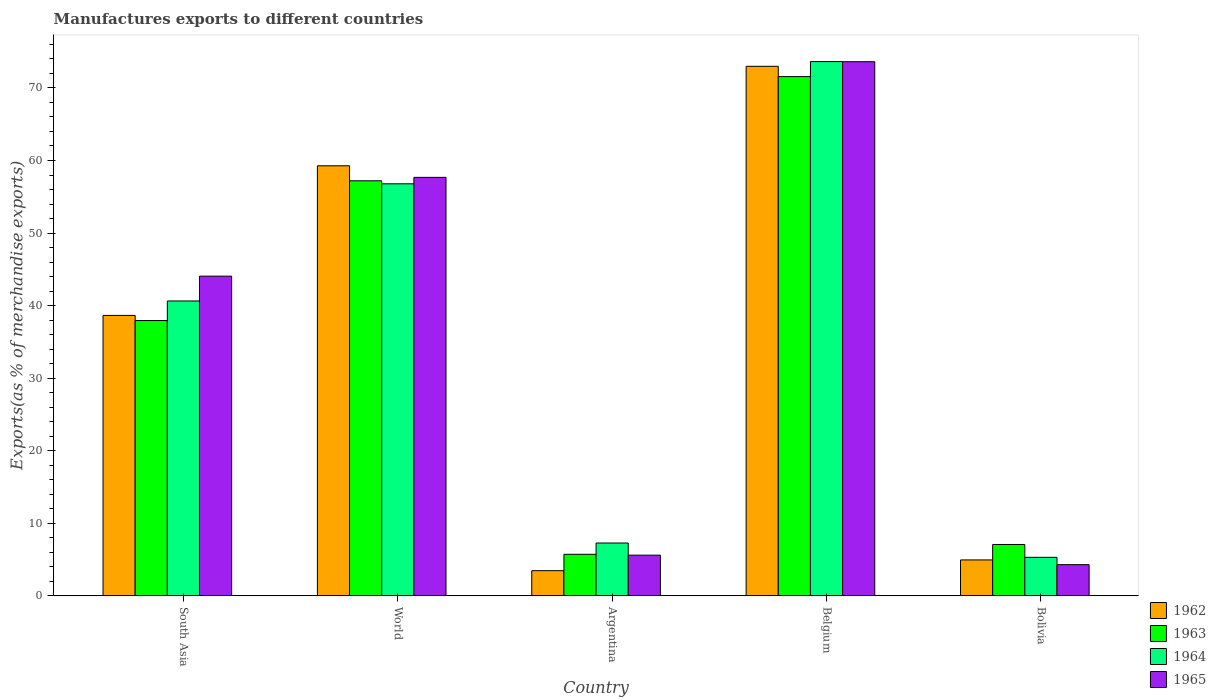How many different coloured bars are there?
Give a very brief answer. 4. How many groups of bars are there?
Provide a succinct answer. 5. Are the number of bars per tick equal to the number of legend labels?
Offer a terse response. Yes. How many bars are there on the 3rd tick from the right?
Your answer should be compact. 4. What is the label of the 3rd group of bars from the left?
Your answer should be very brief. Argentina. What is the percentage of exports to different countries in 1965 in World?
Offer a terse response. 57.68. Across all countries, what is the maximum percentage of exports to different countries in 1962?
Your response must be concise. 72.98. Across all countries, what is the minimum percentage of exports to different countries in 1964?
Provide a short and direct response. 5.31. What is the total percentage of exports to different countries in 1965 in the graph?
Offer a terse response. 185.26. What is the difference between the percentage of exports to different countries in 1965 in Bolivia and that in World?
Keep it short and to the point. -53.38. What is the difference between the percentage of exports to different countries in 1965 in Belgium and the percentage of exports to different countries in 1963 in South Asia?
Provide a short and direct response. 35.68. What is the average percentage of exports to different countries in 1963 per country?
Offer a very short reply. 35.9. What is the difference between the percentage of exports to different countries of/in 1962 and percentage of exports to different countries of/in 1963 in Belgium?
Your answer should be compact. 1.42. In how many countries, is the percentage of exports to different countries in 1962 greater than 20 %?
Provide a succinct answer. 3. What is the ratio of the percentage of exports to different countries in 1965 in Belgium to that in South Asia?
Offer a terse response. 1.67. What is the difference between the highest and the second highest percentage of exports to different countries in 1965?
Provide a succinct answer. 29.56. What is the difference between the highest and the lowest percentage of exports to different countries in 1965?
Your answer should be very brief. 69.32. Is the sum of the percentage of exports to different countries in 1963 in Argentina and Bolivia greater than the maximum percentage of exports to different countries in 1962 across all countries?
Make the answer very short. No. What does the 3rd bar from the left in Argentina represents?
Give a very brief answer. 1964. What does the 2nd bar from the right in Belgium represents?
Provide a short and direct response. 1964. Is it the case that in every country, the sum of the percentage of exports to different countries in 1963 and percentage of exports to different countries in 1964 is greater than the percentage of exports to different countries in 1962?
Offer a terse response. Yes. Are all the bars in the graph horizontal?
Offer a very short reply. No. What is the difference between two consecutive major ticks on the Y-axis?
Your response must be concise. 10. Are the values on the major ticks of Y-axis written in scientific E-notation?
Provide a succinct answer. No. Where does the legend appear in the graph?
Make the answer very short. Bottom right. What is the title of the graph?
Your answer should be very brief. Manufactures exports to different countries. What is the label or title of the Y-axis?
Offer a very short reply. Exports(as % of merchandise exports). What is the Exports(as % of merchandise exports) of 1962 in South Asia?
Ensure brevity in your answer.  38.65. What is the Exports(as % of merchandise exports) of 1963 in South Asia?
Your answer should be very brief. 37.94. What is the Exports(as % of merchandise exports) of 1964 in South Asia?
Your answer should be compact. 40.64. What is the Exports(as % of merchandise exports) in 1965 in South Asia?
Keep it short and to the point. 44.06. What is the Exports(as % of merchandise exports) of 1962 in World?
Offer a terse response. 59.27. What is the Exports(as % of merchandise exports) of 1963 in World?
Your answer should be very brief. 57.2. What is the Exports(as % of merchandise exports) in 1964 in World?
Offer a terse response. 56.79. What is the Exports(as % of merchandise exports) in 1965 in World?
Make the answer very short. 57.68. What is the Exports(as % of merchandise exports) of 1962 in Argentina?
Offer a very short reply. 3.47. What is the Exports(as % of merchandise exports) in 1963 in Argentina?
Give a very brief answer. 5.73. What is the Exports(as % of merchandise exports) in 1964 in Argentina?
Your answer should be compact. 7.28. What is the Exports(as % of merchandise exports) in 1965 in Argentina?
Your answer should be very brief. 5.61. What is the Exports(as % of merchandise exports) of 1962 in Belgium?
Your answer should be compact. 72.98. What is the Exports(as % of merchandise exports) of 1963 in Belgium?
Provide a short and direct response. 71.56. What is the Exports(as % of merchandise exports) in 1964 in Belgium?
Your answer should be very brief. 73.63. What is the Exports(as % of merchandise exports) of 1965 in Belgium?
Ensure brevity in your answer.  73.62. What is the Exports(as % of merchandise exports) in 1962 in Bolivia?
Your response must be concise. 4.95. What is the Exports(as % of merchandise exports) of 1963 in Bolivia?
Your answer should be very brief. 7.08. What is the Exports(as % of merchandise exports) of 1964 in Bolivia?
Provide a succinct answer. 5.31. What is the Exports(as % of merchandise exports) of 1965 in Bolivia?
Provide a succinct answer. 4.3. Across all countries, what is the maximum Exports(as % of merchandise exports) of 1962?
Your response must be concise. 72.98. Across all countries, what is the maximum Exports(as % of merchandise exports) in 1963?
Offer a terse response. 71.56. Across all countries, what is the maximum Exports(as % of merchandise exports) of 1964?
Offer a terse response. 73.63. Across all countries, what is the maximum Exports(as % of merchandise exports) of 1965?
Your answer should be compact. 73.62. Across all countries, what is the minimum Exports(as % of merchandise exports) of 1962?
Ensure brevity in your answer.  3.47. Across all countries, what is the minimum Exports(as % of merchandise exports) of 1963?
Give a very brief answer. 5.73. Across all countries, what is the minimum Exports(as % of merchandise exports) in 1964?
Offer a terse response. 5.31. Across all countries, what is the minimum Exports(as % of merchandise exports) of 1965?
Offer a very short reply. 4.3. What is the total Exports(as % of merchandise exports) in 1962 in the graph?
Provide a succinct answer. 179.32. What is the total Exports(as % of merchandise exports) in 1963 in the graph?
Keep it short and to the point. 179.51. What is the total Exports(as % of merchandise exports) in 1964 in the graph?
Offer a terse response. 183.65. What is the total Exports(as % of merchandise exports) in 1965 in the graph?
Your response must be concise. 185.26. What is the difference between the Exports(as % of merchandise exports) in 1962 in South Asia and that in World?
Offer a terse response. -20.62. What is the difference between the Exports(as % of merchandise exports) of 1963 in South Asia and that in World?
Keep it short and to the point. -19.26. What is the difference between the Exports(as % of merchandise exports) of 1964 in South Asia and that in World?
Keep it short and to the point. -16.15. What is the difference between the Exports(as % of merchandise exports) in 1965 in South Asia and that in World?
Provide a short and direct response. -13.62. What is the difference between the Exports(as % of merchandise exports) of 1962 in South Asia and that in Argentina?
Make the answer very short. 35.18. What is the difference between the Exports(as % of merchandise exports) in 1963 in South Asia and that in Argentina?
Offer a terse response. 32.21. What is the difference between the Exports(as % of merchandise exports) in 1964 in South Asia and that in Argentina?
Your response must be concise. 33.36. What is the difference between the Exports(as % of merchandise exports) of 1965 in South Asia and that in Argentina?
Your answer should be very brief. 38.45. What is the difference between the Exports(as % of merchandise exports) of 1962 in South Asia and that in Belgium?
Keep it short and to the point. -34.33. What is the difference between the Exports(as % of merchandise exports) in 1963 in South Asia and that in Belgium?
Make the answer very short. -33.62. What is the difference between the Exports(as % of merchandise exports) of 1964 in South Asia and that in Belgium?
Provide a short and direct response. -32.99. What is the difference between the Exports(as % of merchandise exports) in 1965 in South Asia and that in Belgium?
Provide a succinct answer. -29.56. What is the difference between the Exports(as % of merchandise exports) in 1962 in South Asia and that in Bolivia?
Your answer should be very brief. 33.7. What is the difference between the Exports(as % of merchandise exports) of 1963 in South Asia and that in Bolivia?
Provide a short and direct response. 30.86. What is the difference between the Exports(as % of merchandise exports) in 1964 in South Asia and that in Bolivia?
Your response must be concise. 35.33. What is the difference between the Exports(as % of merchandise exports) of 1965 in South Asia and that in Bolivia?
Keep it short and to the point. 39.76. What is the difference between the Exports(as % of merchandise exports) of 1962 in World and that in Argentina?
Keep it short and to the point. 55.8. What is the difference between the Exports(as % of merchandise exports) in 1963 in World and that in Argentina?
Offer a terse response. 51.48. What is the difference between the Exports(as % of merchandise exports) of 1964 in World and that in Argentina?
Your response must be concise. 49.51. What is the difference between the Exports(as % of merchandise exports) of 1965 in World and that in Argentina?
Provide a short and direct response. 52.07. What is the difference between the Exports(as % of merchandise exports) in 1962 in World and that in Belgium?
Your answer should be very brief. -13.71. What is the difference between the Exports(as % of merchandise exports) in 1963 in World and that in Belgium?
Make the answer very short. -14.36. What is the difference between the Exports(as % of merchandise exports) in 1964 in World and that in Belgium?
Offer a terse response. -16.84. What is the difference between the Exports(as % of merchandise exports) of 1965 in World and that in Belgium?
Give a very brief answer. -15.94. What is the difference between the Exports(as % of merchandise exports) of 1962 in World and that in Bolivia?
Offer a terse response. 54.32. What is the difference between the Exports(as % of merchandise exports) of 1963 in World and that in Bolivia?
Ensure brevity in your answer.  50.12. What is the difference between the Exports(as % of merchandise exports) in 1964 in World and that in Bolivia?
Offer a very short reply. 51.48. What is the difference between the Exports(as % of merchandise exports) in 1965 in World and that in Bolivia?
Give a very brief answer. 53.38. What is the difference between the Exports(as % of merchandise exports) of 1962 in Argentina and that in Belgium?
Ensure brevity in your answer.  -69.51. What is the difference between the Exports(as % of merchandise exports) of 1963 in Argentina and that in Belgium?
Your answer should be very brief. -65.84. What is the difference between the Exports(as % of merchandise exports) of 1964 in Argentina and that in Belgium?
Make the answer very short. -66.35. What is the difference between the Exports(as % of merchandise exports) in 1965 in Argentina and that in Belgium?
Your answer should be very brief. -68.01. What is the difference between the Exports(as % of merchandise exports) of 1962 in Argentina and that in Bolivia?
Your answer should be compact. -1.48. What is the difference between the Exports(as % of merchandise exports) of 1963 in Argentina and that in Bolivia?
Provide a short and direct response. -1.35. What is the difference between the Exports(as % of merchandise exports) of 1964 in Argentina and that in Bolivia?
Provide a short and direct response. 1.97. What is the difference between the Exports(as % of merchandise exports) in 1965 in Argentina and that in Bolivia?
Ensure brevity in your answer.  1.31. What is the difference between the Exports(as % of merchandise exports) of 1962 in Belgium and that in Bolivia?
Offer a terse response. 68.03. What is the difference between the Exports(as % of merchandise exports) in 1963 in Belgium and that in Bolivia?
Make the answer very short. 64.48. What is the difference between the Exports(as % of merchandise exports) of 1964 in Belgium and that in Bolivia?
Provide a short and direct response. 68.32. What is the difference between the Exports(as % of merchandise exports) of 1965 in Belgium and that in Bolivia?
Give a very brief answer. 69.32. What is the difference between the Exports(as % of merchandise exports) in 1962 in South Asia and the Exports(as % of merchandise exports) in 1963 in World?
Your answer should be compact. -18.56. What is the difference between the Exports(as % of merchandise exports) of 1962 in South Asia and the Exports(as % of merchandise exports) of 1964 in World?
Make the answer very short. -18.14. What is the difference between the Exports(as % of merchandise exports) in 1962 in South Asia and the Exports(as % of merchandise exports) in 1965 in World?
Make the answer very short. -19.03. What is the difference between the Exports(as % of merchandise exports) in 1963 in South Asia and the Exports(as % of merchandise exports) in 1964 in World?
Provide a short and direct response. -18.85. What is the difference between the Exports(as % of merchandise exports) in 1963 in South Asia and the Exports(as % of merchandise exports) in 1965 in World?
Make the answer very short. -19.74. What is the difference between the Exports(as % of merchandise exports) in 1964 in South Asia and the Exports(as % of merchandise exports) in 1965 in World?
Offer a terse response. -17.04. What is the difference between the Exports(as % of merchandise exports) of 1962 in South Asia and the Exports(as % of merchandise exports) of 1963 in Argentina?
Offer a terse response. 32.92. What is the difference between the Exports(as % of merchandise exports) of 1962 in South Asia and the Exports(as % of merchandise exports) of 1964 in Argentina?
Your response must be concise. 31.37. What is the difference between the Exports(as % of merchandise exports) in 1962 in South Asia and the Exports(as % of merchandise exports) in 1965 in Argentina?
Keep it short and to the point. 33.04. What is the difference between the Exports(as % of merchandise exports) of 1963 in South Asia and the Exports(as % of merchandise exports) of 1964 in Argentina?
Keep it short and to the point. 30.66. What is the difference between the Exports(as % of merchandise exports) in 1963 in South Asia and the Exports(as % of merchandise exports) in 1965 in Argentina?
Your response must be concise. 32.33. What is the difference between the Exports(as % of merchandise exports) of 1964 in South Asia and the Exports(as % of merchandise exports) of 1965 in Argentina?
Your response must be concise. 35.03. What is the difference between the Exports(as % of merchandise exports) of 1962 in South Asia and the Exports(as % of merchandise exports) of 1963 in Belgium?
Provide a short and direct response. -32.92. What is the difference between the Exports(as % of merchandise exports) of 1962 in South Asia and the Exports(as % of merchandise exports) of 1964 in Belgium?
Give a very brief answer. -34.98. What is the difference between the Exports(as % of merchandise exports) in 1962 in South Asia and the Exports(as % of merchandise exports) in 1965 in Belgium?
Ensure brevity in your answer.  -34.97. What is the difference between the Exports(as % of merchandise exports) in 1963 in South Asia and the Exports(as % of merchandise exports) in 1964 in Belgium?
Give a very brief answer. -35.69. What is the difference between the Exports(as % of merchandise exports) in 1963 in South Asia and the Exports(as % of merchandise exports) in 1965 in Belgium?
Provide a short and direct response. -35.68. What is the difference between the Exports(as % of merchandise exports) of 1964 in South Asia and the Exports(as % of merchandise exports) of 1965 in Belgium?
Your answer should be compact. -32.98. What is the difference between the Exports(as % of merchandise exports) of 1962 in South Asia and the Exports(as % of merchandise exports) of 1963 in Bolivia?
Your answer should be compact. 31.57. What is the difference between the Exports(as % of merchandise exports) in 1962 in South Asia and the Exports(as % of merchandise exports) in 1964 in Bolivia?
Give a very brief answer. 33.34. What is the difference between the Exports(as % of merchandise exports) in 1962 in South Asia and the Exports(as % of merchandise exports) in 1965 in Bolivia?
Give a very brief answer. 34.35. What is the difference between the Exports(as % of merchandise exports) of 1963 in South Asia and the Exports(as % of merchandise exports) of 1964 in Bolivia?
Your answer should be compact. 32.63. What is the difference between the Exports(as % of merchandise exports) of 1963 in South Asia and the Exports(as % of merchandise exports) of 1965 in Bolivia?
Keep it short and to the point. 33.64. What is the difference between the Exports(as % of merchandise exports) in 1964 in South Asia and the Exports(as % of merchandise exports) in 1965 in Bolivia?
Offer a very short reply. 36.34. What is the difference between the Exports(as % of merchandise exports) in 1962 in World and the Exports(as % of merchandise exports) in 1963 in Argentina?
Offer a very short reply. 53.55. What is the difference between the Exports(as % of merchandise exports) in 1962 in World and the Exports(as % of merchandise exports) in 1964 in Argentina?
Offer a terse response. 51.99. What is the difference between the Exports(as % of merchandise exports) in 1962 in World and the Exports(as % of merchandise exports) in 1965 in Argentina?
Provide a short and direct response. 53.66. What is the difference between the Exports(as % of merchandise exports) in 1963 in World and the Exports(as % of merchandise exports) in 1964 in Argentina?
Your answer should be compact. 49.92. What is the difference between the Exports(as % of merchandise exports) in 1963 in World and the Exports(as % of merchandise exports) in 1965 in Argentina?
Keep it short and to the point. 51.59. What is the difference between the Exports(as % of merchandise exports) in 1964 in World and the Exports(as % of merchandise exports) in 1965 in Argentina?
Your answer should be compact. 51.18. What is the difference between the Exports(as % of merchandise exports) in 1962 in World and the Exports(as % of merchandise exports) in 1963 in Belgium?
Your answer should be compact. -12.29. What is the difference between the Exports(as % of merchandise exports) of 1962 in World and the Exports(as % of merchandise exports) of 1964 in Belgium?
Keep it short and to the point. -14.36. What is the difference between the Exports(as % of merchandise exports) in 1962 in World and the Exports(as % of merchandise exports) in 1965 in Belgium?
Your answer should be compact. -14.35. What is the difference between the Exports(as % of merchandise exports) in 1963 in World and the Exports(as % of merchandise exports) in 1964 in Belgium?
Provide a short and direct response. -16.43. What is the difference between the Exports(as % of merchandise exports) of 1963 in World and the Exports(as % of merchandise exports) of 1965 in Belgium?
Keep it short and to the point. -16.41. What is the difference between the Exports(as % of merchandise exports) of 1964 in World and the Exports(as % of merchandise exports) of 1965 in Belgium?
Your answer should be very brief. -16.83. What is the difference between the Exports(as % of merchandise exports) in 1962 in World and the Exports(as % of merchandise exports) in 1963 in Bolivia?
Keep it short and to the point. 52.19. What is the difference between the Exports(as % of merchandise exports) of 1962 in World and the Exports(as % of merchandise exports) of 1964 in Bolivia?
Give a very brief answer. 53.96. What is the difference between the Exports(as % of merchandise exports) in 1962 in World and the Exports(as % of merchandise exports) in 1965 in Bolivia?
Provide a short and direct response. 54.97. What is the difference between the Exports(as % of merchandise exports) of 1963 in World and the Exports(as % of merchandise exports) of 1964 in Bolivia?
Make the answer very short. 51.89. What is the difference between the Exports(as % of merchandise exports) in 1963 in World and the Exports(as % of merchandise exports) in 1965 in Bolivia?
Ensure brevity in your answer.  52.91. What is the difference between the Exports(as % of merchandise exports) of 1964 in World and the Exports(as % of merchandise exports) of 1965 in Bolivia?
Provide a succinct answer. 52.49. What is the difference between the Exports(as % of merchandise exports) of 1962 in Argentina and the Exports(as % of merchandise exports) of 1963 in Belgium?
Your response must be concise. -68.1. What is the difference between the Exports(as % of merchandise exports) in 1962 in Argentina and the Exports(as % of merchandise exports) in 1964 in Belgium?
Keep it short and to the point. -70.16. What is the difference between the Exports(as % of merchandise exports) in 1962 in Argentina and the Exports(as % of merchandise exports) in 1965 in Belgium?
Give a very brief answer. -70.15. What is the difference between the Exports(as % of merchandise exports) of 1963 in Argentina and the Exports(as % of merchandise exports) of 1964 in Belgium?
Ensure brevity in your answer.  -67.91. What is the difference between the Exports(as % of merchandise exports) of 1963 in Argentina and the Exports(as % of merchandise exports) of 1965 in Belgium?
Keep it short and to the point. -67.89. What is the difference between the Exports(as % of merchandise exports) in 1964 in Argentina and the Exports(as % of merchandise exports) in 1965 in Belgium?
Keep it short and to the point. -66.33. What is the difference between the Exports(as % of merchandise exports) in 1962 in Argentina and the Exports(as % of merchandise exports) in 1963 in Bolivia?
Your answer should be very brief. -3.61. What is the difference between the Exports(as % of merchandise exports) of 1962 in Argentina and the Exports(as % of merchandise exports) of 1964 in Bolivia?
Ensure brevity in your answer.  -1.84. What is the difference between the Exports(as % of merchandise exports) of 1962 in Argentina and the Exports(as % of merchandise exports) of 1965 in Bolivia?
Your answer should be compact. -0.83. What is the difference between the Exports(as % of merchandise exports) of 1963 in Argentina and the Exports(as % of merchandise exports) of 1964 in Bolivia?
Ensure brevity in your answer.  0.42. What is the difference between the Exports(as % of merchandise exports) of 1963 in Argentina and the Exports(as % of merchandise exports) of 1965 in Bolivia?
Ensure brevity in your answer.  1.43. What is the difference between the Exports(as % of merchandise exports) of 1964 in Argentina and the Exports(as % of merchandise exports) of 1965 in Bolivia?
Offer a very short reply. 2.98. What is the difference between the Exports(as % of merchandise exports) in 1962 in Belgium and the Exports(as % of merchandise exports) in 1963 in Bolivia?
Make the answer very short. 65.9. What is the difference between the Exports(as % of merchandise exports) in 1962 in Belgium and the Exports(as % of merchandise exports) in 1964 in Bolivia?
Your answer should be compact. 67.67. What is the difference between the Exports(as % of merchandise exports) in 1962 in Belgium and the Exports(as % of merchandise exports) in 1965 in Bolivia?
Offer a terse response. 68.68. What is the difference between the Exports(as % of merchandise exports) in 1963 in Belgium and the Exports(as % of merchandise exports) in 1964 in Bolivia?
Your answer should be very brief. 66.25. What is the difference between the Exports(as % of merchandise exports) in 1963 in Belgium and the Exports(as % of merchandise exports) in 1965 in Bolivia?
Offer a terse response. 67.27. What is the difference between the Exports(as % of merchandise exports) in 1964 in Belgium and the Exports(as % of merchandise exports) in 1965 in Bolivia?
Offer a terse response. 69.34. What is the average Exports(as % of merchandise exports) of 1962 per country?
Ensure brevity in your answer.  35.86. What is the average Exports(as % of merchandise exports) of 1963 per country?
Your answer should be compact. 35.9. What is the average Exports(as % of merchandise exports) of 1964 per country?
Offer a very short reply. 36.73. What is the average Exports(as % of merchandise exports) of 1965 per country?
Your response must be concise. 37.05. What is the difference between the Exports(as % of merchandise exports) of 1962 and Exports(as % of merchandise exports) of 1963 in South Asia?
Ensure brevity in your answer.  0.71. What is the difference between the Exports(as % of merchandise exports) in 1962 and Exports(as % of merchandise exports) in 1964 in South Asia?
Provide a succinct answer. -1.99. What is the difference between the Exports(as % of merchandise exports) of 1962 and Exports(as % of merchandise exports) of 1965 in South Asia?
Offer a terse response. -5.41. What is the difference between the Exports(as % of merchandise exports) in 1963 and Exports(as % of merchandise exports) in 1964 in South Asia?
Your answer should be very brief. -2.7. What is the difference between the Exports(as % of merchandise exports) in 1963 and Exports(as % of merchandise exports) in 1965 in South Asia?
Give a very brief answer. -6.12. What is the difference between the Exports(as % of merchandise exports) in 1964 and Exports(as % of merchandise exports) in 1965 in South Asia?
Offer a very short reply. -3.42. What is the difference between the Exports(as % of merchandise exports) in 1962 and Exports(as % of merchandise exports) in 1963 in World?
Provide a succinct answer. 2.07. What is the difference between the Exports(as % of merchandise exports) of 1962 and Exports(as % of merchandise exports) of 1964 in World?
Offer a very short reply. 2.48. What is the difference between the Exports(as % of merchandise exports) of 1962 and Exports(as % of merchandise exports) of 1965 in World?
Provide a short and direct response. 1.59. What is the difference between the Exports(as % of merchandise exports) of 1963 and Exports(as % of merchandise exports) of 1964 in World?
Provide a succinct answer. 0.41. What is the difference between the Exports(as % of merchandise exports) in 1963 and Exports(as % of merchandise exports) in 1965 in World?
Your answer should be very brief. -0.47. What is the difference between the Exports(as % of merchandise exports) of 1964 and Exports(as % of merchandise exports) of 1965 in World?
Your answer should be compact. -0.89. What is the difference between the Exports(as % of merchandise exports) in 1962 and Exports(as % of merchandise exports) in 1963 in Argentina?
Offer a terse response. -2.26. What is the difference between the Exports(as % of merchandise exports) of 1962 and Exports(as % of merchandise exports) of 1964 in Argentina?
Keep it short and to the point. -3.81. What is the difference between the Exports(as % of merchandise exports) of 1962 and Exports(as % of merchandise exports) of 1965 in Argentina?
Your answer should be compact. -2.14. What is the difference between the Exports(as % of merchandise exports) in 1963 and Exports(as % of merchandise exports) in 1964 in Argentina?
Give a very brief answer. -1.56. What is the difference between the Exports(as % of merchandise exports) of 1963 and Exports(as % of merchandise exports) of 1965 in Argentina?
Keep it short and to the point. 0.12. What is the difference between the Exports(as % of merchandise exports) in 1964 and Exports(as % of merchandise exports) in 1965 in Argentina?
Your answer should be compact. 1.67. What is the difference between the Exports(as % of merchandise exports) of 1962 and Exports(as % of merchandise exports) of 1963 in Belgium?
Make the answer very short. 1.42. What is the difference between the Exports(as % of merchandise exports) of 1962 and Exports(as % of merchandise exports) of 1964 in Belgium?
Provide a short and direct response. -0.65. What is the difference between the Exports(as % of merchandise exports) in 1962 and Exports(as % of merchandise exports) in 1965 in Belgium?
Make the answer very short. -0.64. What is the difference between the Exports(as % of merchandise exports) in 1963 and Exports(as % of merchandise exports) in 1964 in Belgium?
Ensure brevity in your answer.  -2.07. What is the difference between the Exports(as % of merchandise exports) in 1963 and Exports(as % of merchandise exports) in 1965 in Belgium?
Your response must be concise. -2.05. What is the difference between the Exports(as % of merchandise exports) of 1964 and Exports(as % of merchandise exports) of 1965 in Belgium?
Keep it short and to the point. 0.02. What is the difference between the Exports(as % of merchandise exports) in 1962 and Exports(as % of merchandise exports) in 1963 in Bolivia?
Your answer should be very brief. -2.13. What is the difference between the Exports(as % of merchandise exports) in 1962 and Exports(as % of merchandise exports) in 1964 in Bolivia?
Make the answer very short. -0.36. What is the difference between the Exports(as % of merchandise exports) in 1962 and Exports(as % of merchandise exports) in 1965 in Bolivia?
Your answer should be very brief. 0.65. What is the difference between the Exports(as % of merchandise exports) in 1963 and Exports(as % of merchandise exports) in 1964 in Bolivia?
Provide a succinct answer. 1.77. What is the difference between the Exports(as % of merchandise exports) in 1963 and Exports(as % of merchandise exports) in 1965 in Bolivia?
Your answer should be compact. 2.78. What is the difference between the Exports(as % of merchandise exports) in 1964 and Exports(as % of merchandise exports) in 1965 in Bolivia?
Offer a very short reply. 1.01. What is the ratio of the Exports(as % of merchandise exports) of 1962 in South Asia to that in World?
Ensure brevity in your answer.  0.65. What is the ratio of the Exports(as % of merchandise exports) in 1963 in South Asia to that in World?
Your response must be concise. 0.66. What is the ratio of the Exports(as % of merchandise exports) of 1964 in South Asia to that in World?
Give a very brief answer. 0.72. What is the ratio of the Exports(as % of merchandise exports) in 1965 in South Asia to that in World?
Your response must be concise. 0.76. What is the ratio of the Exports(as % of merchandise exports) in 1962 in South Asia to that in Argentina?
Provide a short and direct response. 11.14. What is the ratio of the Exports(as % of merchandise exports) of 1963 in South Asia to that in Argentina?
Give a very brief answer. 6.63. What is the ratio of the Exports(as % of merchandise exports) of 1964 in South Asia to that in Argentina?
Your response must be concise. 5.58. What is the ratio of the Exports(as % of merchandise exports) of 1965 in South Asia to that in Argentina?
Your answer should be very brief. 7.86. What is the ratio of the Exports(as % of merchandise exports) of 1962 in South Asia to that in Belgium?
Your response must be concise. 0.53. What is the ratio of the Exports(as % of merchandise exports) of 1963 in South Asia to that in Belgium?
Your answer should be very brief. 0.53. What is the ratio of the Exports(as % of merchandise exports) of 1964 in South Asia to that in Belgium?
Make the answer very short. 0.55. What is the ratio of the Exports(as % of merchandise exports) of 1965 in South Asia to that in Belgium?
Ensure brevity in your answer.  0.6. What is the ratio of the Exports(as % of merchandise exports) of 1962 in South Asia to that in Bolivia?
Provide a short and direct response. 7.81. What is the ratio of the Exports(as % of merchandise exports) of 1963 in South Asia to that in Bolivia?
Give a very brief answer. 5.36. What is the ratio of the Exports(as % of merchandise exports) in 1964 in South Asia to that in Bolivia?
Make the answer very short. 7.65. What is the ratio of the Exports(as % of merchandise exports) in 1965 in South Asia to that in Bolivia?
Keep it short and to the point. 10.25. What is the ratio of the Exports(as % of merchandise exports) in 1962 in World to that in Argentina?
Your answer should be compact. 17.09. What is the ratio of the Exports(as % of merchandise exports) of 1963 in World to that in Argentina?
Make the answer very short. 9.99. What is the ratio of the Exports(as % of merchandise exports) of 1964 in World to that in Argentina?
Provide a short and direct response. 7.8. What is the ratio of the Exports(as % of merchandise exports) in 1965 in World to that in Argentina?
Your answer should be very brief. 10.28. What is the ratio of the Exports(as % of merchandise exports) of 1962 in World to that in Belgium?
Give a very brief answer. 0.81. What is the ratio of the Exports(as % of merchandise exports) of 1963 in World to that in Belgium?
Ensure brevity in your answer.  0.8. What is the ratio of the Exports(as % of merchandise exports) in 1964 in World to that in Belgium?
Your response must be concise. 0.77. What is the ratio of the Exports(as % of merchandise exports) of 1965 in World to that in Belgium?
Give a very brief answer. 0.78. What is the ratio of the Exports(as % of merchandise exports) in 1962 in World to that in Bolivia?
Make the answer very short. 11.97. What is the ratio of the Exports(as % of merchandise exports) of 1963 in World to that in Bolivia?
Your answer should be very brief. 8.08. What is the ratio of the Exports(as % of merchandise exports) in 1964 in World to that in Bolivia?
Provide a short and direct response. 10.7. What is the ratio of the Exports(as % of merchandise exports) of 1965 in World to that in Bolivia?
Your response must be concise. 13.42. What is the ratio of the Exports(as % of merchandise exports) of 1962 in Argentina to that in Belgium?
Offer a terse response. 0.05. What is the ratio of the Exports(as % of merchandise exports) of 1963 in Argentina to that in Belgium?
Your response must be concise. 0.08. What is the ratio of the Exports(as % of merchandise exports) in 1964 in Argentina to that in Belgium?
Ensure brevity in your answer.  0.1. What is the ratio of the Exports(as % of merchandise exports) in 1965 in Argentina to that in Belgium?
Give a very brief answer. 0.08. What is the ratio of the Exports(as % of merchandise exports) of 1962 in Argentina to that in Bolivia?
Give a very brief answer. 0.7. What is the ratio of the Exports(as % of merchandise exports) in 1963 in Argentina to that in Bolivia?
Offer a very short reply. 0.81. What is the ratio of the Exports(as % of merchandise exports) in 1964 in Argentina to that in Bolivia?
Your response must be concise. 1.37. What is the ratio of the Exports(as % of merchandise exports) of 1965 in Argentina to that in Bolivia?
Provide a succinct answer. 1.31. What is the ratio of the Exports(as % of merchandise exports) of 1962 in Belgium to that in Bolivia?
Offer a very short reply. 14.74. What is the ratio of the Exports(as % of merchandise exports) of 1963 in Belgium to that in Bolivia?
Ensure brevity in your answer.  10.11. What is the ratio of the Exports(as % of merchandise exports) of 1964 in Belgium to that in Bolivia?
Offer a very short reply. 13.87. What is the ratio of the Exports(as % of merchandise exports) of 1965 in Belgium to that in Bolivia?
Offer a very short reply. 17.13. What is the difference between the highest and the second highest Exports(as % of merchandise exports) in 1962?
Make the answer very short. 13.71. What is the difference between the highest and the second highest Exports(as % of merchandise exports) in 1963?
Ensure brevity in your answer.  14.36. What is the difference between the highest and the second highest Exports(as % of merchandise exports) of 1964?
Keep it short and to the point. 16.84. What is the difference between the highest and the second highest Exports(as % of merchandise exports) of 1965?
Make the answer very short. 15.94. What is the difference between the highest and the lowest Exports(as % of merchandise exports) in 1962?
Give a very brief answer. 69.51. What is the difference between the highest and the lowest Exports(as % of merchandise exports) in 1963?
Provide a short and direct response. 65.84. What is the difference between the highest and the lowest Exports(as % of merchandise exports) in 1964?
Provide a succinct answer. 68.32. What is the difference between the highest and the lowest Exports(as % of merchandise exports) in 1965?
Ensure brevity in your answer.  69.32. 